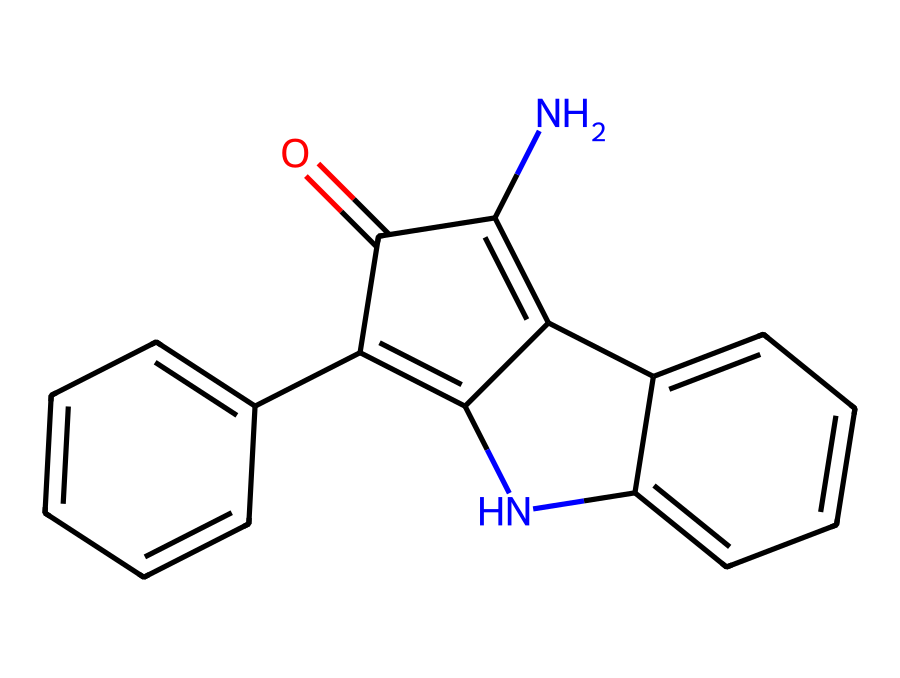What is the molecular formula of this compound? To determine the molecular formula, you need to count the number of each type of atom present in the molecule based on the SMILES representation. The provided SMILES indicates the presence of 12 carbons (C), 11 hydrogens (H), 2 nitrogens (N), and 1 oxygen (O), leading to the formula C12H11N2O.
Answer: C12H11N2O How many rings are in this structure? By analyzing the structure represented by the SMILES, you can identify that there are three cyclic components (or rings) present. This can be seen by the presence of "C1", "C2", and "C3" indicators in the SMILES, which denote the start and close of rings.
Answer: 3 What are the functional groups in this dye? Identifying functional groups requires looking for specific patterns or structures within the molecule. The presence of a carbonyl (C=O) and amine (N) functionalities in the structure suggests that the dye contains both of these functional groups.
Answer: carbonyl and amine Is this dye water-soluble? Natural indigo is known to have low water solubility due to its hydrophobic aromatic nature, despite having some polar groups. The structure suggests limited interaction with water, making it generally not water-soluble.
Answer: no What type of dye is represented by this structure? The presence of indole-like structures and the arrangement of chromophores indicates that this compound corresponds to a type of organic dye. Specifically, this represents an indigo dye which is known for its use in textile applications.
Answer: organic dye What role do the nitrogen atoms play in this dye? The nitrogen atoms in this chemical structure contribute to the dye's ability to form bonds with cellulose in fabrics, enhancing the dyeing properties and colorfastness, thus playing a key role in its functionality as a dye.
Answer: bonding How does this dye's structure affect its color? The conjugated system of double bonds and the arrangement of the aromatic rings allows for the absorption of specific wavelengths of light, which is responsible for the blue color characteristic of indigo dyes.
Answer: blue color 